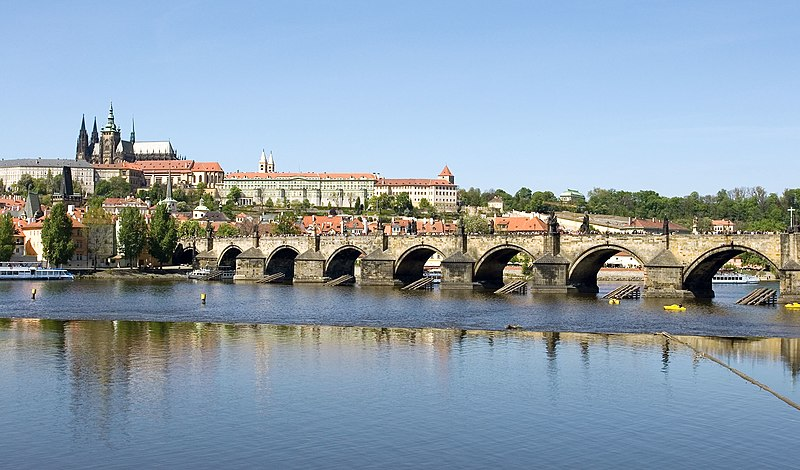Can you describe the main features of this image for me? The image captures the historic Charles Bridge, an iconic structure in Prague, Czech Republic. This stone bridge spans the serene waters of the Vltava River and is famous for its series of statues that line both sides. The photograph is taken from a distance, providing a full view of the bridge and its architectural details. Surrounding the bridge are beautiful buildings showcasing diverse architectural styles and vibrant red and orange rooftops. These buildings are reflected in the calm river below, creating a picturesque scene. Above, the clear blue sky adds to the image's overall tranquility and charm. The image beautifully illustrates Prague's rich history and stunning architecture. 